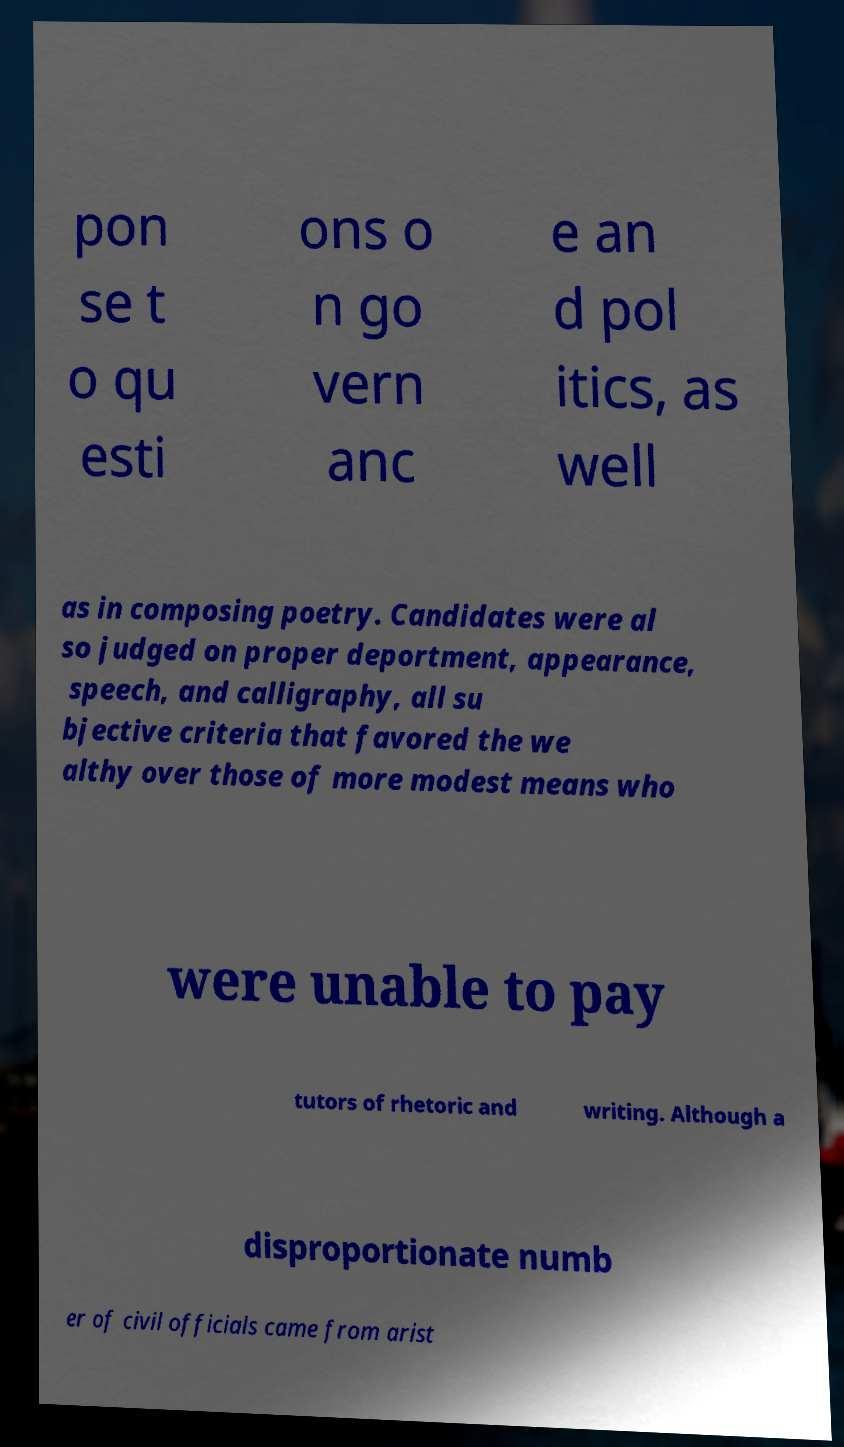What messages or text are displayed in this image? I need them in a readable, typed format. pon se t o qu esti ons o n go vern anc e an d pol itics, as well as in composing poetry. Candidates were al so judged on proper deportment, appearance, speech, and calligraphy, all su bjective criteria that favored the we althy over those of more modest means who were unable to pay tutors of rhetoric and writing. Although a disproportionate numb er of civil officials came from arist 